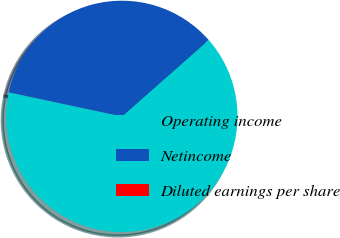Convert chart. <chart><loc_0><loc_0><loc_500><loc_500><pie_chart><fcel>Operating income<fcel>Netincome<fcel>Diluted earnings per share<nl><fcel>64.84%<fcel>35.16%<fcel>0.0%<nl></chart> 